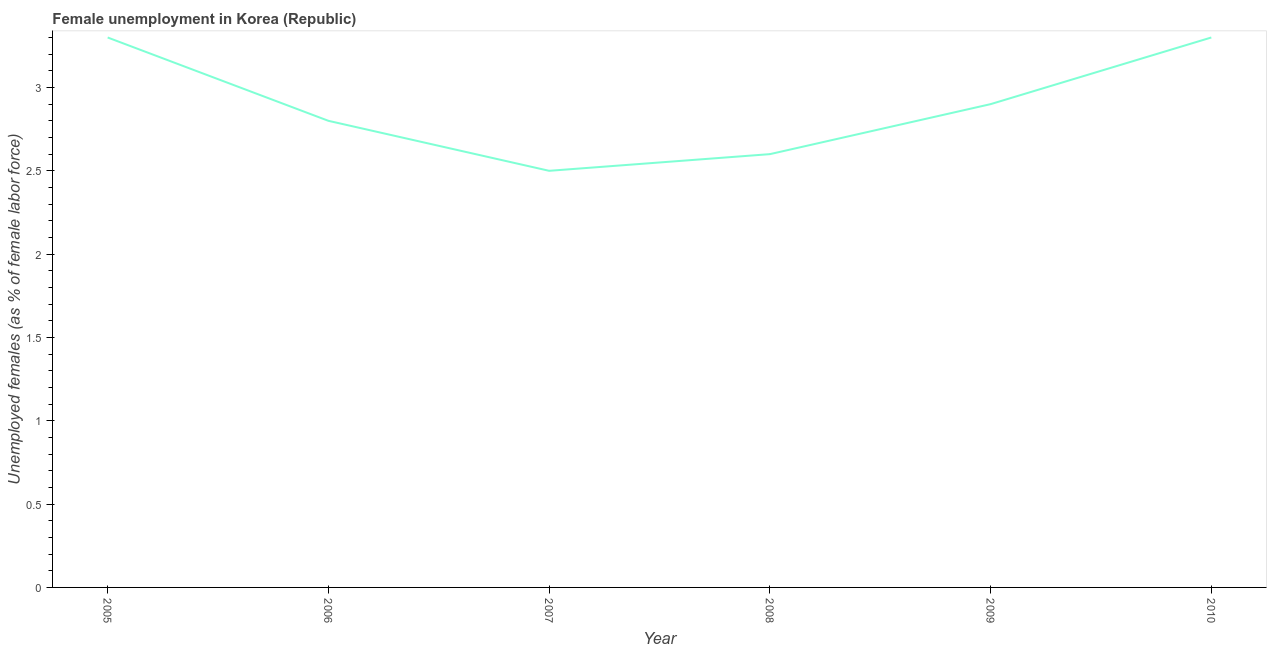What is the unemployed females population in 2009?
Offer a very short reply. 2.9. Across all years, what is the maximum unemployed females population?
Ensure brevity in your answer.  3.3. In which year was the unemployed females population maximum?
Your answer should be very brief. 2005. What is the sum of the unemployed females population?
Make the answer very short. 17.4. What is the difference between the unemployed females population in 2008 and 2009?
Offer a terse response. -0.3. What is the average unemployed females population per year?
Your answer should be compact. 2.9. What is the median unemployed females population?
Offer a very short reply. 2.85. What is the ratio of the unemployed females population in 2005 to that in 2008?
Ensure brevity in your answer.  1.27. Is the difference between the unemployed females population in 2007 and 2009 greater than the difference between any two years?
Offer a very short reply. No. What is the difference between the highest and the lowest unemployed females population?
Provide a short and direct response. 0.8. Does the unemployed females population monotonically increase over the years?
Make the answer very short. No. How many lines are there?
Your answer should be very brief. 1. How many years are there in the graph?
Your answer should be compact. 6. What is the difference between two consecutive major ticks on the Y-axis?
Your answer should be compact. 0.5. Are the values on the major ticks of Y-axis written in scientific E-notation?
Give a very brief answer. No. Does the graph contain any zero values?
Offer a very short reply. No. What is the title of the graph?
Provide a succinct answer. Female unemployment in Korea (Republic). What is the label or title of the X-axis?
Offer a terse response. Year. What is the label or title of the Y-axis?
Provide a short and direct response. Unemployed females (as % of female labor force). What is the Unemployed females (as % of female labor force) of 2005?
Offer a terse response. 3.3. What is the Unemployed females (as % of female labor force) in 2006?
Offer a terse response. 2.8. What is the Unemployed females (as % of female labor force) in 2007?
Provide a succinct answer. 2.5. What is the Unemployed females (as % of female labor force) of 2008?
Keep it short and to the point. 2.6. What is the Unemployed females (as % of female labor force) in 2009?
Offer a terse response. 2.9. What is the Unemployed females (as % of female labor force) of 2010?
Give a very brief answer. 3.3. What is the difference between the Unemployed females (as % of female labor force) in 2005 and 2006?
Your answer should be compact. 0.5. What is the difference between the Unemployed females (as % of female labor force) in 2005 and 2007?
Your answer should be compact. 0.8. What is the difference between the Unemployed females (as % of female labor force) in 2005 and 2008?
Your response must be concise. 0.7. What is the difference between the Unemployed females (as % of female labor force) in 2005 and 2009?
Ensure brevity in your answer.  0.4. What is the difference between the Unemployed females (as % of female labor force) in 2006 and 2008?
Offer a terse response. 0.2. What is the difference between the Unemployed females (as % of female labor force) in 2006 and 2010?
Give a very brief answer. -0.5. What is the difference between the Unemployed females (as % of female labor force) in 2007 and 2008?
Keep it short and to the point. -0.1. What is the difference between the Unemployed females (as % of female labor force) in 2007 and 2009?
Make the answer very short. -0.4. What is the difference between the Unemployed females (as % of female labor force) in 2007 and 2010?
Provide a short and direct response. -0.8. What is the difference between the Unemployed females (as % of female labor force) in 2008 and 2009?
Provide a short and direct response. -0.3. What is the ratio of the Unemployed females (as % of female labor force) in 2005 to that in 2006?
Your answer should be very brief. 1.18. What is the ratio of the Unemployed females (as % of female labor force) in 2005 to that in 2007?
Your answer should be very brief. 1.32. What is the ratio of the Unemployed females (as % of female labor force) in 2005 to that in 2008?
Make the answer very short. 1.27. What is the ratio of the Unemployed females (as % of female labor force) in 2005 to that in 2009?
Your answer should be compact. 1.14. What is the ratio of the Unemployed females (as % of female labor force) in 2006 to that in 2007?
Ensure brevity in your answer.  1.12. What is the ratio of the Unemployed females (as % of female labor force) in 2006 to that in 2008?
Your answer should be compact. 1.08. What is the ratio of the Unemployed females (as % of female labor force) in 2006 to that in 2009?
Provide a short and direct response. 0.97. What is the ratio of the Unemployed females (as % of female labor force) in 2006 to that in 2010?
Keep it short and to the point. 0.85. What is the ratio of the Unemployed females (as % of female labor force) in 2007 to that in 2009?
Your answer should be compact. 0.86. What is the ratio of the Unemployed females (as % of female labor force) in 2007 to that in 2010?
Your response must be concise. 0.76. What is the ratio of the Unemployed females (as % of female labor force) in 2008 to that in 2009?
Provide a short and direct response. 0.9. What is the ratio of the Unemployed females (as % of female labor force) in 2008 to that in 2010?
Your answer should be compact. 0.79. What is the ratio of the Unemployed females (as % of female labor force) in 2009 to that in 2010?
Give a very brief answer. 0.88. 